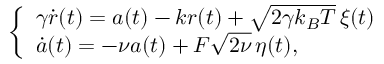Convert formula to latex. <formula><loc_0><loc_0><loc_500><loc_500>\left \{ \begin{array} { l l } { \gamma \dot { r } ( t ) = a ( t ) - k r ( t ) + \sqrt { 2 \gamma k _ { B } T } \, \xi ( t ) } \\ { \dot { a } ( t ) = - \nu a ( t ) + F \sqrt { 2 \nu } \, \eta ( t ) , } \end{array}</formula> 